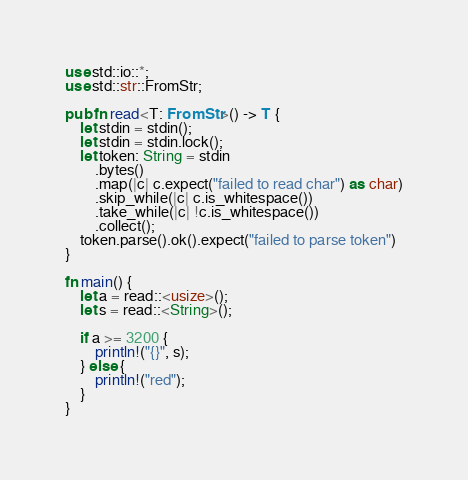Convert code to text. <code><loc_0><loc_0><loc_500><loc_500><_Rust_>use std::io::*;
use std::str::FromStr;

pub fn read<T: FromStr>() -> T {
    let stdin = stdin();
    let stdin = stdin.lock();
    let token: String = stdin
        .bytes()
        .map(|c| c.expect("failed to read char") as char)
        .skip_while(|c| c.is_whitespace())
        .take_while(|c| !c.is_whitespace())
        .collect();
    token.parse().ok().expect("failed to parse token")
}

fn main() {
    let a = read::<usize>();
    let s = read::<String>();

    if a >= 3200 {
        println!("{}", s);
    } else {
        println!("red");
    }
}
</code> 